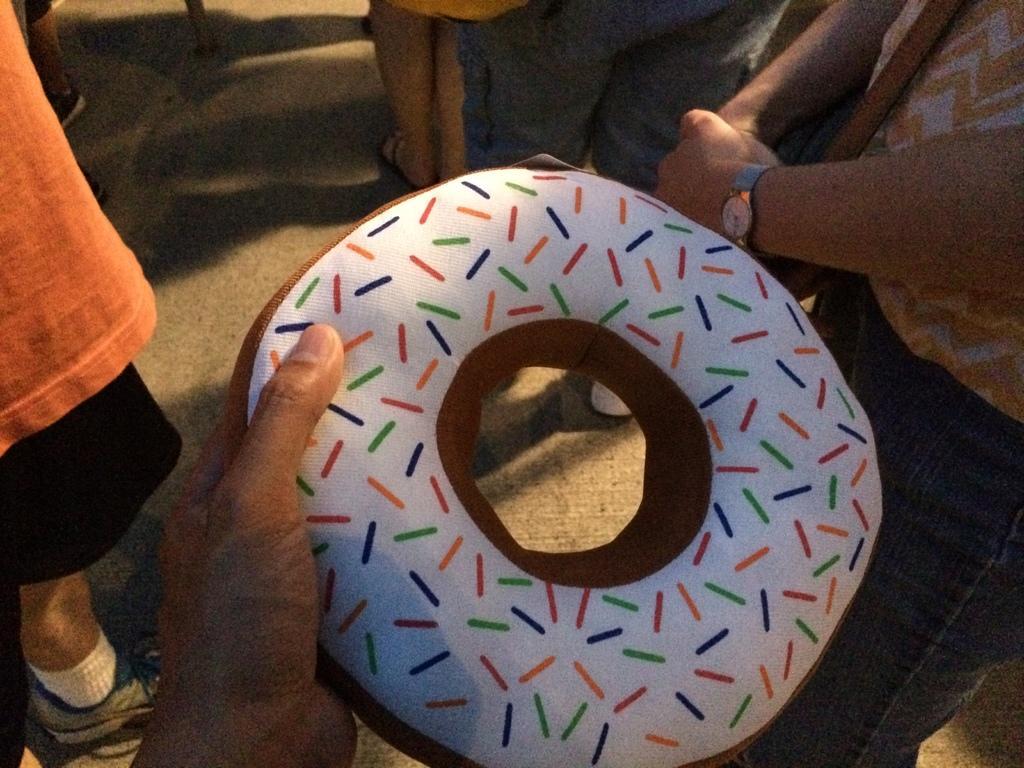Could you give a brief overview of what you see in this image? In this image, we can see some people standing, at the middle there is a person holding a white and brown color object. 